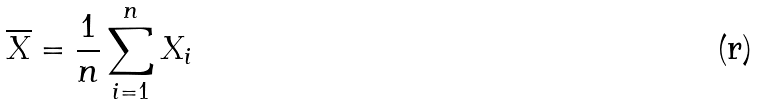<formula> <loc_0><loc_0><loc_500><loc_500>\overline { X } = \frac { 1 } { n } \sum _ { i = 1 } ^ { n } X _ { i }</formula> 